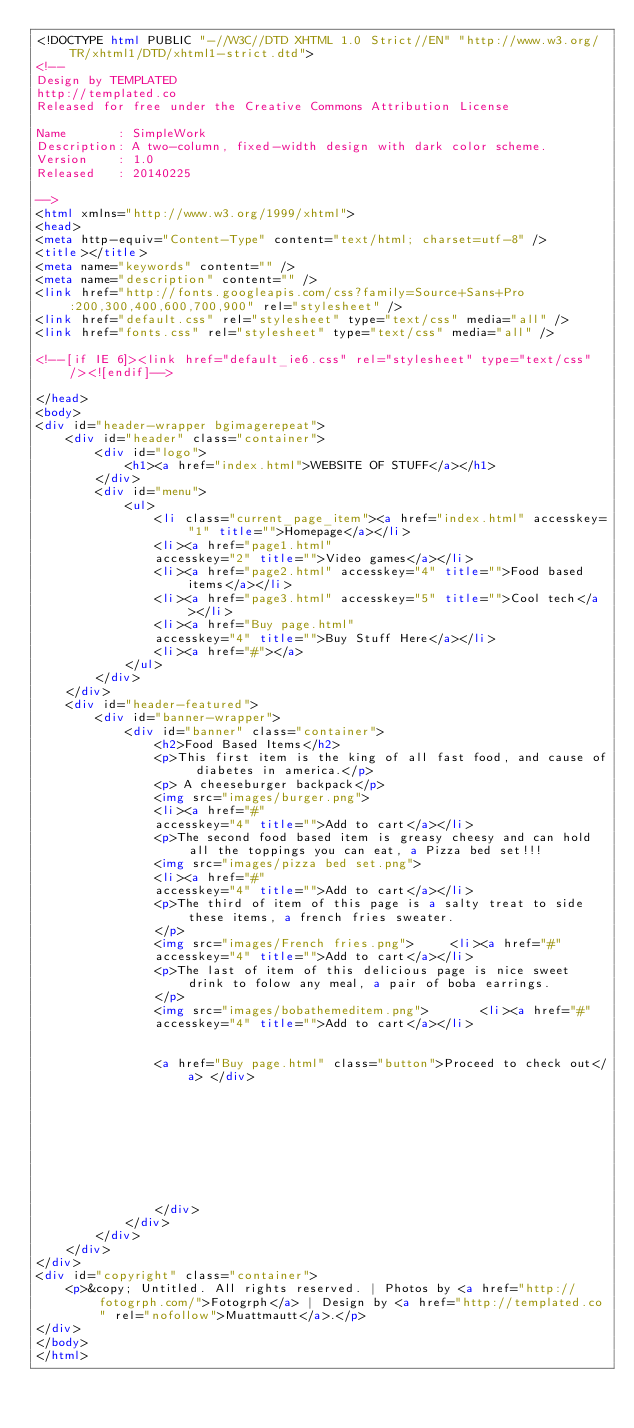Convert code to text. <code><loc_0><loc_0><loc_500><loc_500><_HTML_><!DOCTYPE html PUBLIC "-//W3C//DTD XHTML 1.0 Strict//EN" "http://www.w3.org/TR/xhtml1/DTD/xhtml1-strict.dtd">
<!--
Design by TEMPLATED
http://templated.co
Released for free under the Creative Commons Attribution License

Name       : SimpleWork 
Description: A two-column, fixed-width design with dark color scheme.
Version    : 1.0
Released   : 20140225

-->
<html xmlns="http://www.w3.org/1999/xhtml">
<head>
<meta http-equiv="Content-Type" content="text/html; charset=utf-8" />
<title></title>
<meta name="keywords" content="" />
<meta name="description" content="" />
<link href="http://fonts.googleapis.com/css?family=Source+Sans+Pro:200,300,400,600,700,900" rel="stylesheet" />
<link href="default.css" rel="stylesheet" type="text/css" media="all" />
<link href="fonts.css" rel="stylesheet" type="text/css" media="all" />

<!--[if IE 6]><link href="default_ie6.css" rel="stylesheet" type="text/css" /><![endif]-->

</head>
<body>
<div id="header-wrapper bgimagerepeat">
	<div id="header" class="container">
		<div id="logo">
			<h1><a href="index.html">WEBSITE OF STUFF</a></h1>
		</div>
		<div id="menu">
			<ul>
				<li class="current_page_item"><a href="index.html" accesskey="1" title="">Homepage</a></li>
				<li><a href="page1.html" 
				accesskey="2" title="">Video games</a></li>
				<li><a href="page2.html" accesskey="4" title="">Food based items</a></li>
				<li><a href="page3.html" accesskey="5" title="">Cool tech</a></li>
				<li><a href="Buy page.html"
				accesskey="4" title="">Buy Stuff Here</a></li>
				<li><a href="#"></a> 
			</ul>
		</div>
	</div>
	<div id="header-featured">
		<div id="banner-wrapper">
			<div id="banner" class="container">
				<h2>Food Based Items</h2>
				<p>This first item is the king of all fast food, and cause of diabetes in america.</p>
				<p> A cheeseburger backpack</p>
				<img src="images/burger.png">
				<li><a href="#"
				accesskey="4" title="">Add to cart</a></li>
				<p>The second food based item is greasy cheesy and can hold all the toppings you can eat, a Pizza bed set!!!
				<img src="images/pizza bed set.png">
				<li><a href="#"
				accesskey="4" title="">Add to cart</a></li>
				<p>The third of item of this page is a salty treat to side these items, a french fries sweater.
				</p>	
				<img src="images/French fries.png">		<li><a href="#"
				accesskey="4" title="">Add to cart</a></li>	
				<p>The last of item of this delicious page is nice sweet drink to folow any meal, a pair of boba earrings.
				</p>	
				<img src="images/bobathemeditem.png">		<li><a href="#"
				accesskey="4" title="">Add to cart</a></li>	


				<a href="Buy page.html" class="button">Proceed to check out</a> </div>																																																																				

			


		
				</div>
			</div>
		</div>
	</div>
</div>
<div id="copyright" class="container">
	<p>&copy; Untitled. All rights reserved. | Photos by <a href="http://fotogrph.com/">Fotogrph</a> | Design by <a href="http://templated.co" rel="nofollow">Muattmautt</a>.</p>
</div>
</body>
</html>
</code> 